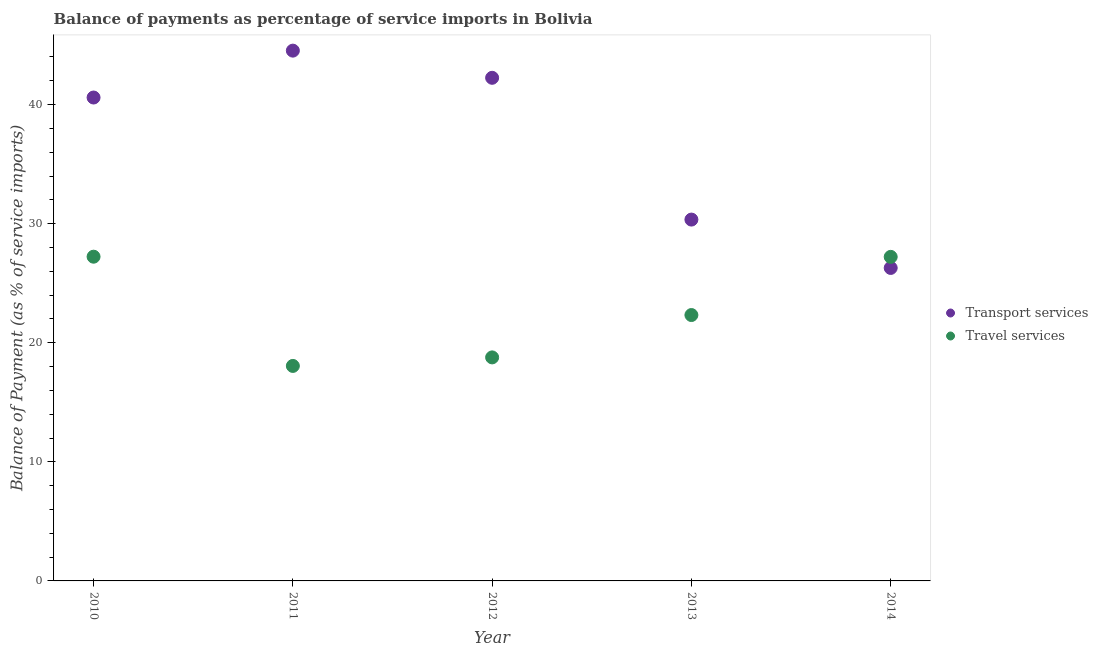What is the balance of payments of transport services in 2012?
Offer a very short reply. 42.25. Across all years, what is the maximum balance of payments of travel services?
Provide a short and direct response. 27.23. Across all years, what is the minimum balance of payments of travel services?
Make the answer very short. 18.06. In which year was the balance of payments of travel services maximum?
Give a very brief answer. 2010. In which year was the balance of payments of travel services minimum?
Make the answer very short. 2011. What is the total balance of payments of transport services in the graph?
Offer a terse response. 184.01. What is the difference between the balance of payments of transport services in 2011 and that in 2014?
Make the answer very short. 18.25. What is the difference between the balance of payments of travel services in 2010 and the balance of payments of transport services in 2013?
Keep it short and to the point. -3.12. What is the average balance of payments of travel services per year?
Offer a very short reply. 22.72. In the year 2013, what is the difference between the balance of payments of travel services and balance of payments of transport services?
Your response must be concise. -8.02. What is the ratio of the balance of payments of travel services in 2010 to that in 2011?
Offer a very short reply. 1.51. Is the balance of payments of travel services in 2010 less than that in 2014?
Provide a short and direct response. No. What is the difference between the highest and the second highest balance of payments of travel services?
Make the answer very short. 0.01. What is the difference between the highest and the lowest balance of payments of travel services?
Give a very brief answer. 9.17. In how many years, is the balance of payments of travel services greater than the average balance of payments of travel services taken over all years?
Your answer should be compact. 2. Is the sum of the balance of payments of transport services in 2011 and 2013 greater than the maximum balance of payments of travel services across all years?
Ensure brevity in your answer.  Yes. Is the balance of payments of transport services strictly less than the balance of payments of travel services over the years?
Make the answer very short. No. Are the values on the major ticks of Y-axis written in scientific E-notation?
Offer a very short reply. No. Does the graph contain any zero values?
Your response must be concise. No. Does the graph contain grids?
Provide a succinct answer. No. Where does the legend appear in the graph?
Offer a terse response. Center right. How many legend labels are there?
Offer a terse response. 2. How are the legend labels stacked?
Give a very brief answer. Vertical. What is the title of the graph?
Offer a terse response. Balance of payments as percentage of service imports in Bolivia. Does "Investments" appear as one of the legend labels in the graph?
Your answer should be very brief. No. What is the label or title of the X-axis?
Your response must be concise. Year. What is the label or title of the Y-axis?
Your response must be concise. Balance of Payment (as % of service imports). What is the Balance of Payment (as % of service imports) of Transport services in 2010?
Provide a succinct answer. 40.6. What is the Balance of Payment (as % of service imports) in Travel services in 2010?
Your response must be concise. 27.23. What is the Balance of Payment (as % of service imports) of Transport services in 2011?
Your answer should be compact. 44.53. What is the Balance of Payment (as % of service imports) in Travel services in 2011?
Keep it short and to the point. 18.06. What is the Balance of Payment (as % of service imports) in Transport services in 2012?
Your answer should be compact. 42.25. What is the Balance of Payment (as % of service imports) of Travel services in 2012?
Keep it short and to the point. 18.77. What is the Balance of Payment (as % of service imports) in Transport services in 2013?
Keep it short and to the point. 30.35. What is the Balance of Payment (as % of service imports) of Travel services in 2013?
Ensure brevity in your answer.  22.33. What is the Balance of Payment (as % of service imports) of Transport services in 2014?
Offer a very short reply. 26.28. What is the Balance of Payment (as % of service imports) in Travel services in 2014?
Provide a short and direct response. 27.21. Across all years, what is the maximum Balance of Payment (as % of service imports) in Transport services?
Your answer should be very brief. 44.53. Across all years, what is the maximum Balance of Payment (as % of service imports) of Travel services?
Your answer should be compact. 27.23. Across all years, what is the minimum Balance of Payment (as % of service imports) of Transport services?
Provide a short and direct response. 26.28. Across all years, what is the minimum Balance of Payment (as % of service imports) of Travel services?
Ensure brevity in your answer.  18.06. What is the total Balance of Payment (as % of service imports) in Transport services in the graph?
Provide a succinct answer. 184.01. What is the total Balance of Payment (as % of service imports) in Travel services in the graph?
Your answer should be very brief. 113.6. What is the difference between the Balance of Payment (as % of service imports) of Transport services in 2010 and that in 2011?
Offer a terse response. -3.94. What is the difference between the Balance of Payment (as % of service imports) of Travel services in 2010 and that in 2011?
Your answer should be compact. 9.17. What is the difference between the Balance of Payment (as % of service imports) of Transport services in 2010 and that in 2012?
Give a very brief answer. -1.66. What is the difference between the Balance of Payment (as % of service imports) of Travel services in 2010 and that in 2012?
Keep it short and to the point. 8.46. What is the difference between the Balance of Payment (as % of service imports) in Transport services in 2010 and that in 2013?
Your response must be concise. 10.25. What is the difference between the Balance of Payment (as % of service imports) of Travel services in 2010 and that in 2013?
Give a very brief answer. 4.9. What is the difference between the Balance of Payment (as % of service imports) of Transport services in 2010 and that in 2014?
Offer a terse response. 14.31. What is the difference between the Balance of Payment (as % of service imports) of Travel services in 2010 and that in 2014?
Keep it short and to the point. 0.01. What is the difference between the Balance of Payment (as % of service imports) of Transport services in 2011 and that in 2012?
Ensure brevity in your answer.  2.28. What is the difference between the Balance of Payment (as % of service imports) of Travel services in 2011 and that in 2012?
Make the answer very short. -0.72. What is the difference between the Balance of Payment (as % of service imports) of Transport services in 2011 and that in 2013?
Give a very brief answer. 14.19. What is the difference between the Balance of Payment (as % of service imports) of Travel services in 2011 and that in 2013?
Give a very brief answer. -4.27. What is the difference between the Balance of Payment (as % of service imports) of Transport services in 2011 and that in 2014?
Provide a succinct answer. 18.25. What is the difference between the Balance of Payment (as % of service imports) in Travel services in 2011 and that in 2014?
Provide a succinct answer. -9.16. What is the difference between the Balance of Payment (as % of service imports) of Transport services in 2012 and that in 2013?
Make the answer very short. 11.91. What is the difference between the Balance of Payment (as % of service imports) of Travel services in 2012 and that in 2013?
Provide a succinct answer. -3.56. What is the difference between the Balance of Payment (as % of service imports) in Transport services in 2012 and that in 2014?
Offer a very short reply. 15.97. What is the difference between the Balance of Payment (as % of service imports) of Travel services in 2012 and that in 2014?
Ensure brevity in your answer.  -8.44. What is the difference between the Balance of Payment (as % of service imports) of Transport services in 2013 and that in 2014?
Provide a succinct answer. 4.06. What is the difference between the Balance of Payment (as % of service imports) of Travel services in 2013 and that in 2014?
Keep it short and to the point. -4.88. What is the difference between the Balance of Payment (as % of service imports) in Transport services in 2010 and the Balance of Payment (as % of service imports) in Travel services in 2011?
Provide a succinct answer. 22.54. What is the difference between the Balance of Payment (as % of service imports) in Transport services in 2010 and the Balance of Payment (as % of service imports) in Travel services in 2012?
Ensure brevity in your answer.  21.82. What is the difference between the Balance of Payment (as % of service imports) of Transport services in 2010 and the Balance of Payment (as % of service imports) of Travel services in 2013?
Keep it short and to the point. 18.27. What is the difference between the Balance of Payment (as % of service imports) in Transport services in 2010 and the Balance of Payment (as % of service imports) in Travel services in 2014?
Your response must be concise. 13.38. What is the difference between the Balance of Payment (as % of service imports) of Transport services in 2011 and the Balance of Payment (as % of service imports) of Travel services in 2012?
Provide a short and direct response. 25.76. What is the difference between the Balance of Payment (as % of service imports) of Transport services in 2011 and the Balance of Payment (as % of service imports) of Travel services in 2013?
Give a very brief answer. 22.2. What is the difference between the Balance of Payment (as % of service imports) in Transport services in 2011 and the Balance of Payment (as % of service imports) in Travel services in 2014?
Keep it short and to the point. 17.32. What is the difference between the Balance of Payment (as % of service imports) of Transport services in 2012 and the Balance of Payment (as % of service imports) of Travel services in 2013?
Offer a terse response. 19.92. What is the difference between the Balance of Payment (as % of service imports) in Transport services in 2012 and the Balance of Payment (as % of service imports) in Travel services in 2014?
Give a very brief answer. 15.04. What is the difference between the Balance of Payment (as % of service imports) in Transport services in 2013 and the Balance of Payment (as % of service imports) in Travel services in 2014?
Offer a terse response. 3.13. What is the average Balance of Payment (as % of service imports) in Transport services per year?
Offer a very short reply. 36.8. What is the average Balance of Payment (as % of service imports) of Travel services per year?
Ensure brevity in your answer.  22.72. In the year 2010, what is the difference between the Balance of Payment (as % of service imports) of Transport services and Balance of Payment (as % of service imports) of Travel services?
Offer a very short reply. 13.37. In the year 2011, what is the difference between the Balance of Payment (as % of service imports) of Transport services and Balance of Payment (as % of service imports) of Travel services?
Your answer should be compact. 26.48. In the year 2012, what is the difference between the Balance of Payment (as % of service imports) of Transport services and Balance of Payment (as % of service imports) of Travel services?
Your answer should be compact. 23.48. In the year 2013, what is the difference between the Balance of Payment (as % of service imports) of Transport services and Balance of Payment (as % of service imports) of Travel services?
Your answer should be very brief. 8.02. In the year 2014, what is the difference between the Balance of Payment (as % of service imports) of Transport services and Balance of Payment (as % of service imports) of Travel services?
Your answer should be compact. -0.93. What is the ratio of the Balance of Payment (as % of service imports) of Transport services in 2010 to that in 2011?
Provide a short and direct response. 0.91. What is the ratio of the Balance of Payment (as % of service imports) of Travel services in 2010 to that in 2011?
Keep it short and to the point. 1.51. What is the ratio of the Balance of Payment (as % of service imports) in Transport services in 2010 to that in 2012?
Provide a short and direct response. 0.96. What is the ratio of the Balance of Payment (as % of service imports) in Travel services in 2010 to that in 2012?
Provide a succinct answer. 1.45. What is the ratio of the Balance of Payment (as % of service imports) in Transport services in 2010 to that in 2013?
Keep it short and to the point. 1.34. What is the ratio of the Balance of Payment (as % of service imports) of Travel services in 2010 to that in 2013?
Your answer should be compact. 1.22. What is the ratio of the Balance of Payment (as % of service imports) in Transport services in 2010 to that in 2014?
Keep it short and to the point. 1.54. What is the ratio of the Balance of Payment (as % of service imports) in Travel services in 2010 to that in 2014?
Keep it short and to the point. 1. What is the ratio of the Balance of Payment (as % of service imports) of Transport services in 2011 to that in 2012?
Your answer should be compact. 1.05. What is the ratio of the Balance of Payment (as % of service imports) of Travel services in 2011 to that in 2012?
Make the answer very short. 0.96. What is the ratio of the Balance of Payment (as % of service imports) of Transport services in 2011 to that in 2013?
Keep it short and to the point. 1.47. What is the ratio of the Balance of Payment (as % of service imports) in Travel services in 2011 to that in 2013?
Offer a very short reply. 0.81. What is the ratio of the Balance of Payment (as % of service imports) in Transport services in 2011 to that in 2014?
Offer a very short reply. 1.69. What is the ratio of the Balance of Payment (as % of service imports) in Travel services in 2011 to that in 2014?
Give a very brief answer. 0.66. What is the ratio of the Balance of Payment (as % of service imports) in Transport services in 2012 to that in 2013?
Your answer should be compact. 1.39. What is the ratio of the Balance of Payment (as % of service imports) in Travel services in 2012 to that in 2013?
Provide a short and direct response. 0.84. What is the ratio of the Balance of Payment (as % of service imports) of Transport services in 2012 to that in 2014?
Offer a very short reply. 1.61. What is the ratio of the Balance of Payment (as % of service imports) in Travel services in 2012 to that in 2014?
Offer a terse response. 0.69. What is the ratio of the Balance of Payment (as % of service imports) in Transport services in 2013 to that in 2014?
Ensure brevity in your answer.  1.15. What is the ratio of the Balance of Payment (as % of service imports) in Travel services in 2013 to that in 2014?
Make the answer very short. 0.82. What is the difference between the highest and the second highest Balance of Payment (as % of service imports) in Transport services?
Keep it short and to the point. 2.28. What is the difference between the highest and the second highest Balance of Payment (as % of service imports) in Travel services?
Ensure brevity in your answer.  0.01. What is the difference between the highest and the lowest Balance of Payment (as % of service imports) in Transport services?
Provide a short and direct response. 18.25. What is the difference between the highest and the lowest Balance of Payment (as % of service imports) in Travel services?
Your answer should be compact. 9.17. 